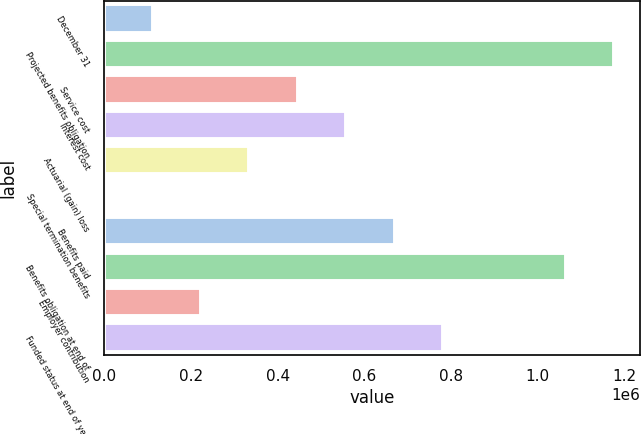Convert chart. <chart><loc_0><loc_0><loc_500><loc_500><bar_chart><fcel>December 31<fcel>Projected benefits obligation<fcel>Service cost<fcel>Interest cost<fcel>Actuarial (gain) loss<fcel>Special termination benefits<fcel>Benefits paid<fcel>Benefits obligation at end of<fcel>Employer contribution<fcel>Funded status at end of year<nl><fcel>111864<fcel>1.17694e+06<fcel>446647<fcel>558242<fcel>335052<fcel>269<fcel>669836<fcel>1.06534e+06<fcel>223458<fcel>781430<nl></chart> 